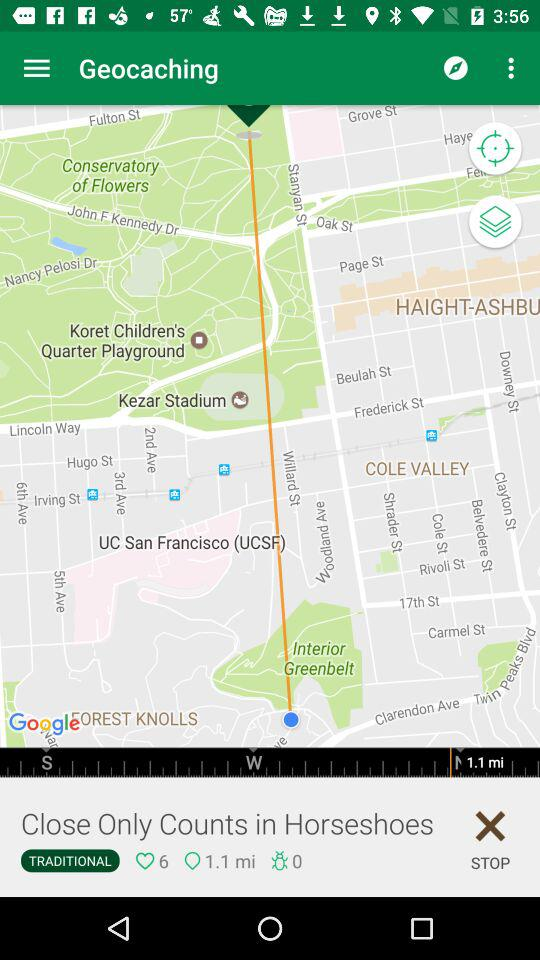How many likes are there? There are 6 likes. 